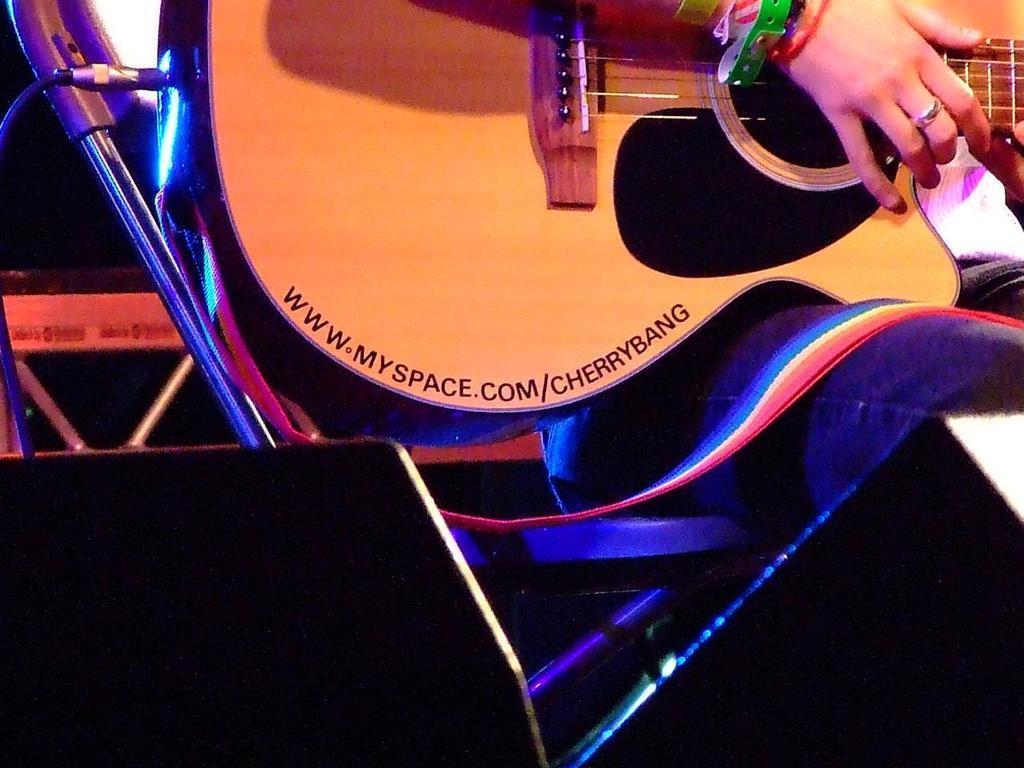In one or two sentences, can you explain what this image depicts? In this picture a half part of the guitar is displayed on which myspace. com/cherrybang is written. We also observe a wire cord which is connected to the bottom of the guitar. 